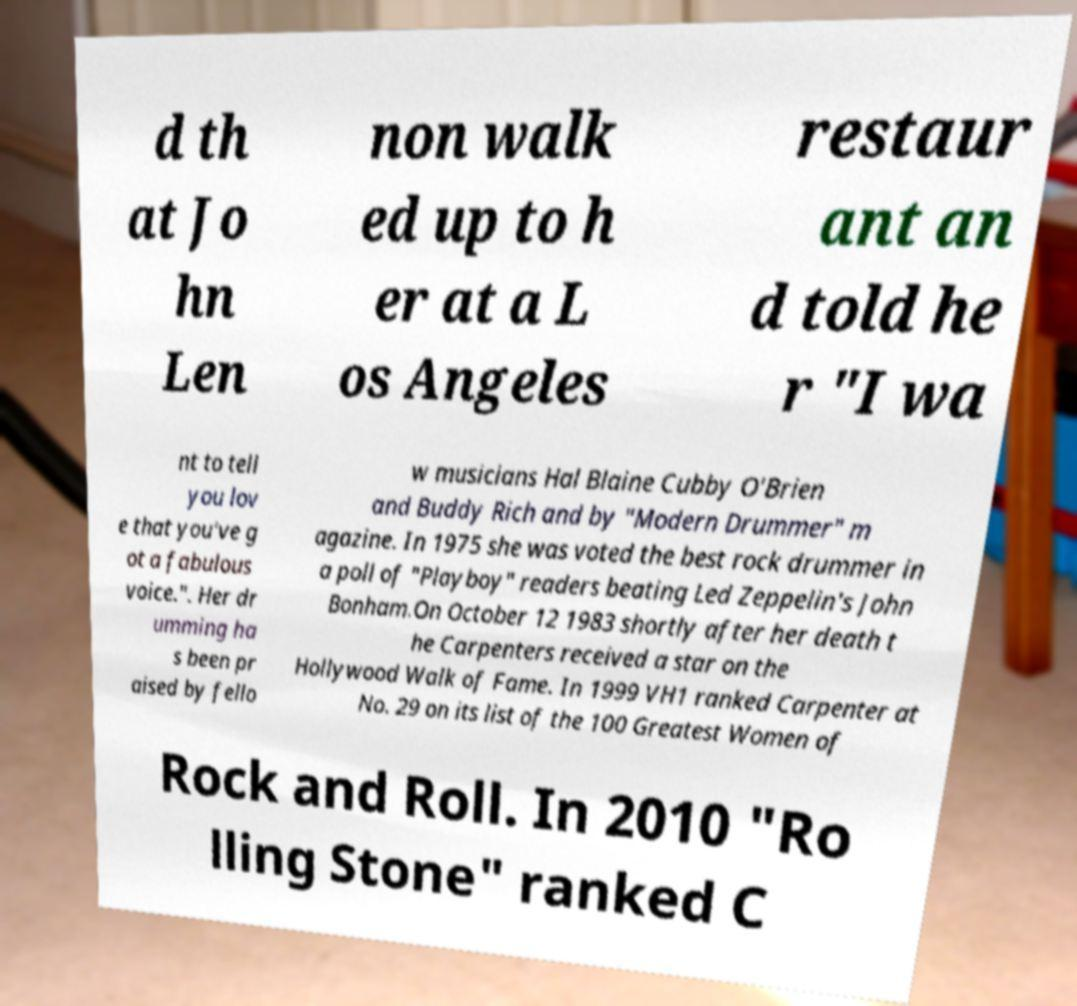Could you assist in decoding the text presented in this image and type it out clearly? d th at Jo hn Len non walk ed up to h er at a L os Angeles restaur ant an d told he r "I wa nt to tell you lov e that you've g ot a fabulous voice.". Her dr umming ha s been pr aised by fello w musicians Hal Blaine Cubby O'Brien and Buddy Rich and by "Modern Drummer" m agazine. In 1975 she was voted the best rock drummer in a poll of "Playboy" readers beating Led Zeppelin's John Bonham.On October 12 1983 shortly after her death t he Carpenters received a star on the Hollywood Walk of Fame. In 1999 VH1 ranked Carpenter at No. 29 on its list of the 100 Greatest Women of Rock and Roll. In 2010 "Ro lling Stone" ranked C 